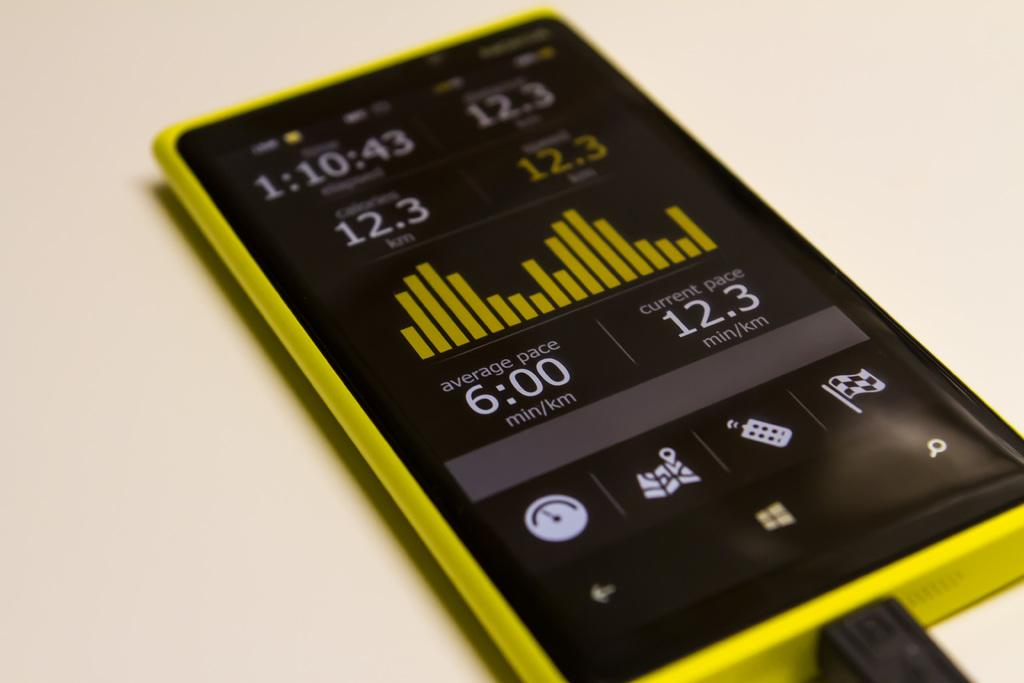<image>
Give a short and clear explanation of the subsequent image. someone's phone with an app that reports average and current paces. 